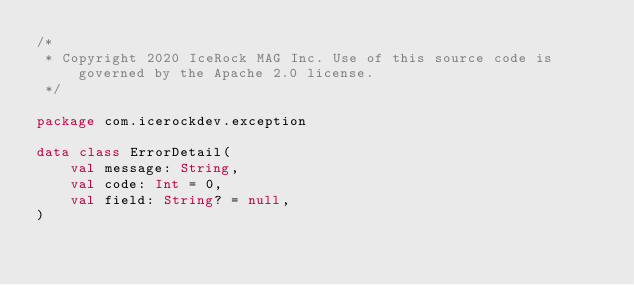Convert code to text. <code><loc_0><loc_0><loc_500><loc_500><_Kotlin_>/*
 * Copyright 2020 IceRock MAG Inc. Use of this source code is governed by the Apache 2.0 license.
 */

package com.icerockdev.exception

data class ErrorDetail(
    val message: String,
    val code: Int = 0,
    val field: String? = null,
)
</code> 